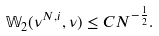Convert formula to latex. <formula><loc_0><loc_0><loc_500><loc_500>\mathbb { W } _ { 2 } ( \nu ^ { N , i } , \nu ) \leq C N ^ { - \frac { 1 } { 2 } } .</formula> 